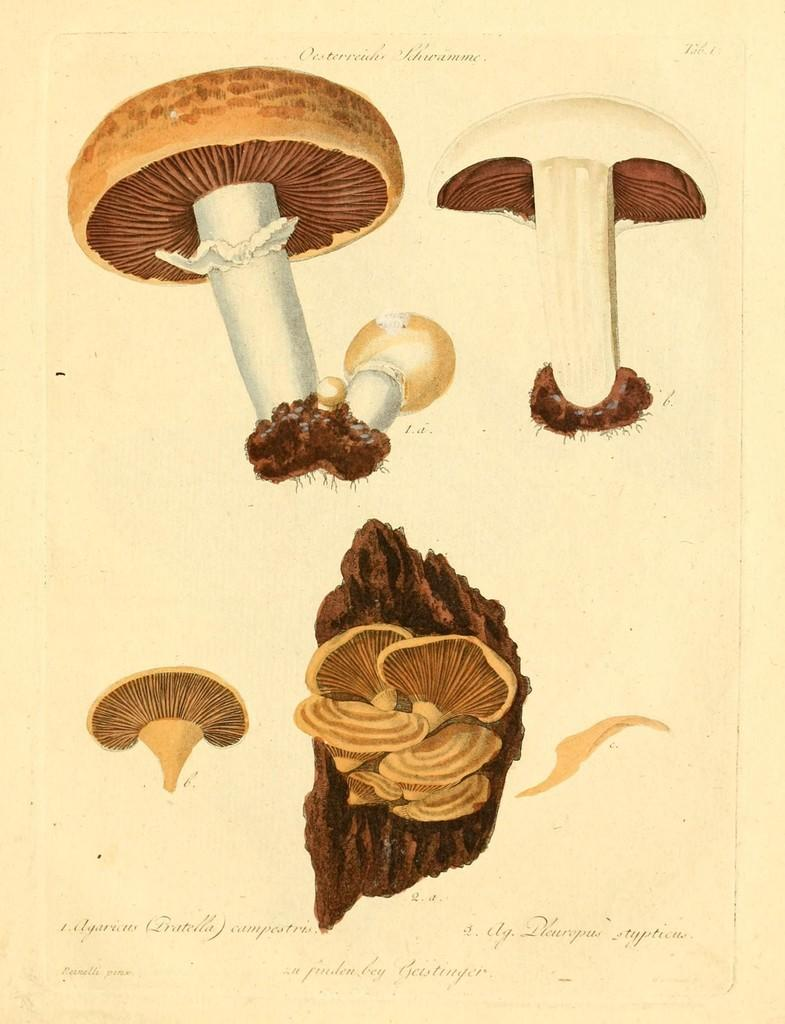What is the medium of the image? The image is on a paper. What type of plants are depicted in the image? There are mushrooms and seeds in the image. Are there any other objects in the image besides plants? Yes, there are other objects in the image. Is there any text in the image? There is writing at the bottom of the image. How many bridges can be seen in the image? There are no bridges present in the image. What type of linen is used to create the image? The image is on a paper, not linen. 